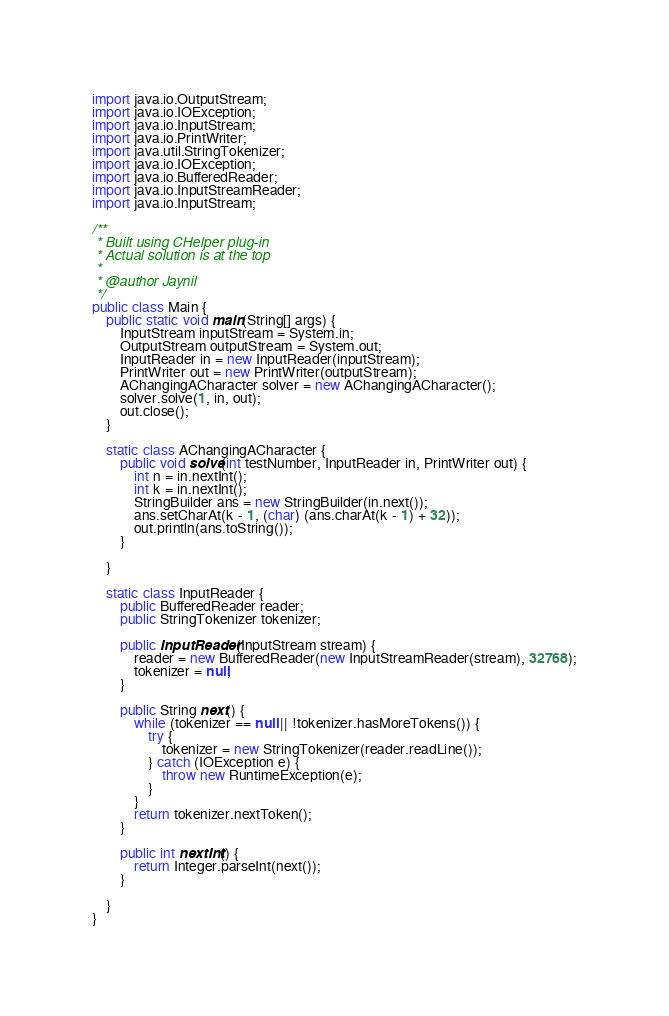<code> <loc_0><loc_0><loc_500><loc_500><_Java_>import java.io.OutputStream;
import java.io.IOException;
import java.io.InputStream;
import java.io.PrintWriter;
import java.util.StringTokenizer;
import java.io.IOException;
import java.io.BufferedReader;
import java.io.InputStreamReader;
import java.io.InputStream;

/**
 * Built using CHelper plug-in
 * Actual solution is at the top
 *
 * @author Jaynil
 */
public class Main {
    public static void main(String[] args) {
        InputStream inputStream = System.in;
        OutputStream outputStream = System.out;
        InputReader in = new InputReader(inputStream);
        PrintWriter out = new PrintWriter(outputStream);
        AChangingACharacter solver = new AChangingACharacter();
        solver.solve(1, in, out);
        out.close();
    }

    static class AChangingACharacter {
        public void solve(int testNumber, InputReader in, PrintWriter out) {
            int n = in.nextInt();
            int k = in.nextInt();
            StringBuilder ans = new StringBuilder(in.next());
            ans.setCharAt(k - 1, (char) (ans.charAt(k - 1) + 32));
            out.println(ans.toString());
        }

    }

    static class InputReader {
        public BufferedReader reader;
        public StringTokenizer tokenizer;

        public InputReader(InputStream stream) {
            reader = new BufferedReader(new InputStreamReader(stream), 32768);
            tokenizer = null;
        }

        public String next() {
            while (tokenizer == null || !tokenizer.hasMoreTokens()) {
                try {
                    tokenizer = new StringTokenizer(reader.readLine());
                } catch (IOException e) {
                    throw new RuntimeException(e);
                }
            }
            return tokenizer.nextToken();
        }

        public int nextInt() {
            return Integer.parseInt(next());
        }

    }
}

</code> 